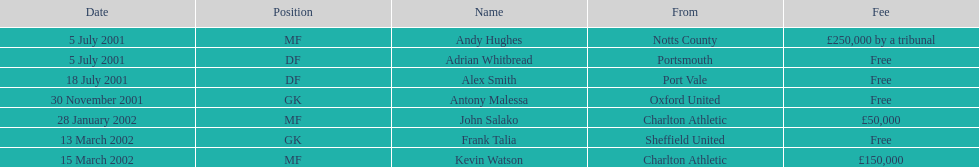Are there no less than 2 nationalities shown on the chart? Yes. 